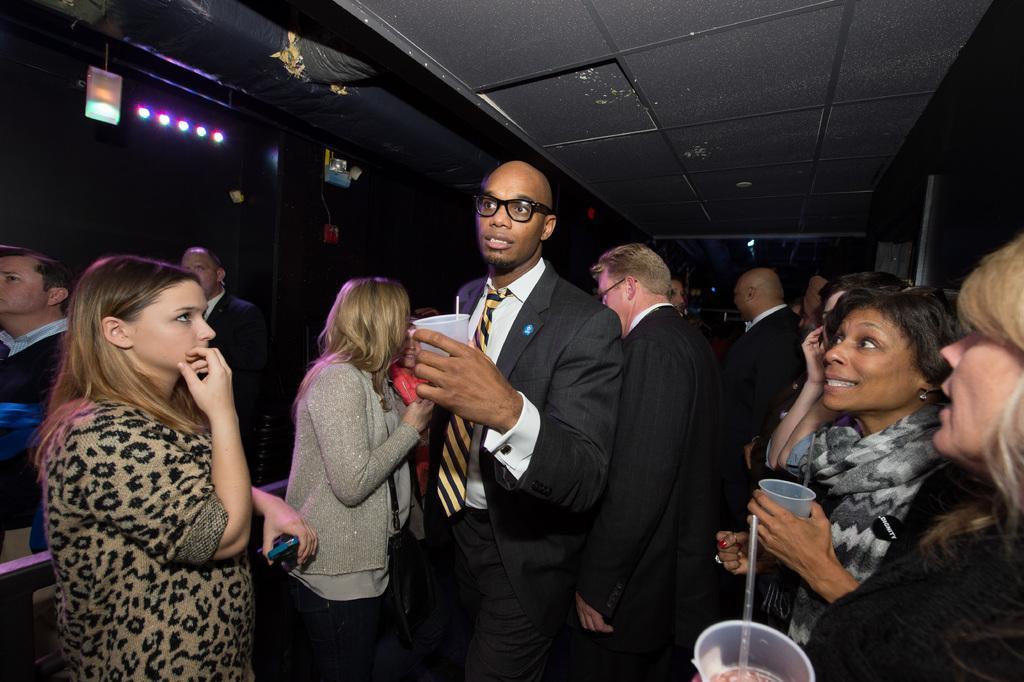How would you summarize this image in a sentence or two? This image is taken indoors. At the top of the image there is a roof. In this image the background is a little dark. There are a few lights. In the middle of the image many people are standing and a few are holding tumblers in their hands. 